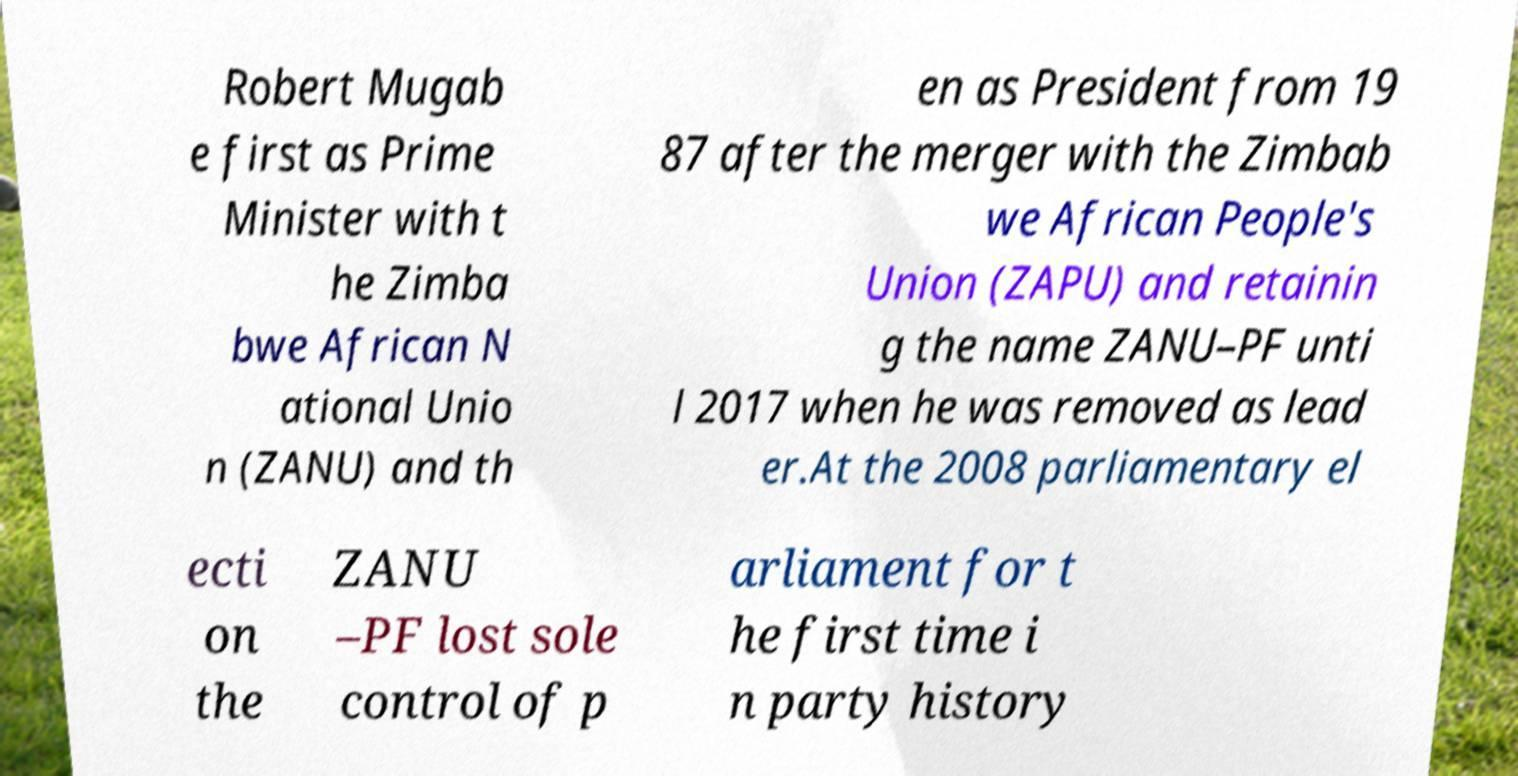Can you accurately transcribe the text from the provided image for me? Robert Mugab e first as Prime Minister with t he Zimba bwe African N ational Unio n (ZANU) and th en as President from 19 87 after the merger with the Zimbab we African People's Union (ZAPU) and retainin g the name ZANU–PF unti l 2017 when he was removed as lead er.At the 2008 parliamentary el ecti on the ZANU –PF lost sole control of p arliament for t he first time i n party history 